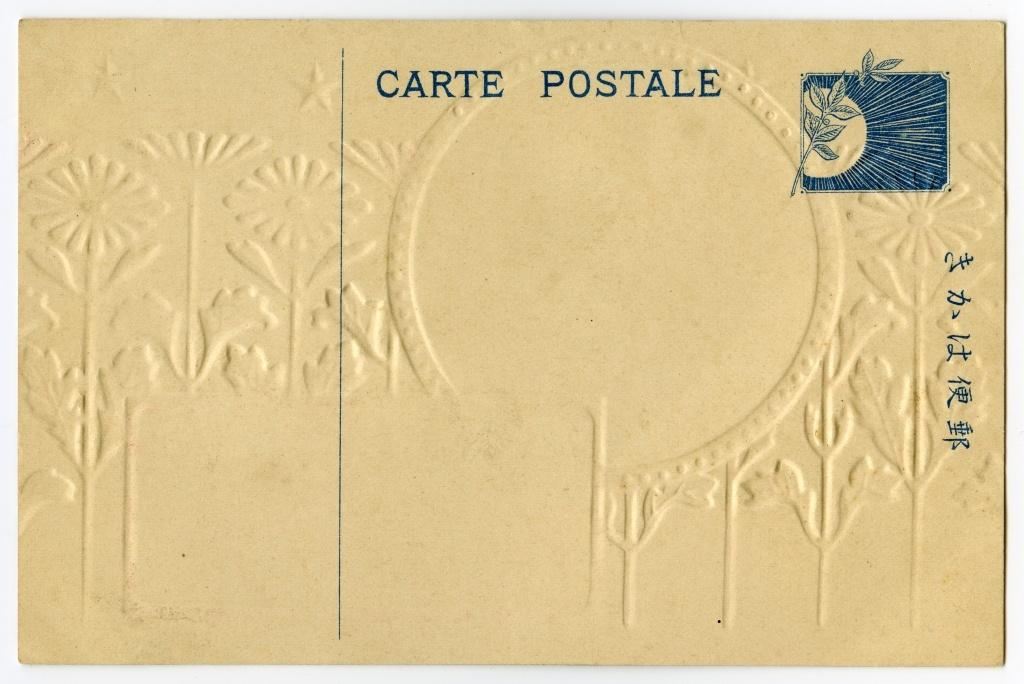<image>
Summarize the visual content of the image. A post letter with Carte Postale stamped on it. 